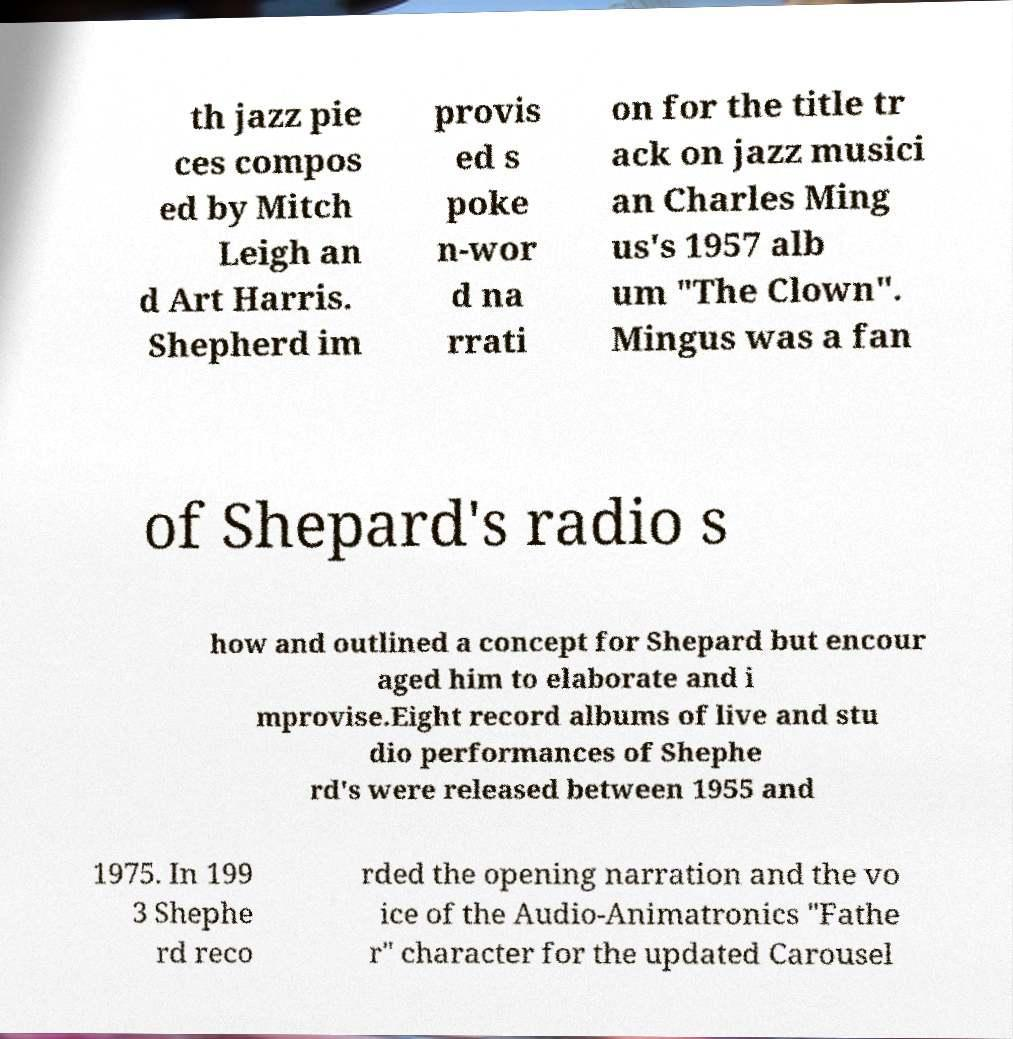Please identify and transcribe the text found in this image. th jazz pie ces compos ed by Mitch Leigh an d Art Harris. Shepherd im provis ed s poke n-wor d na rrati on for the title tr ack on jazz musici an Charles Ming us's 1957 alb um "The Clown". Mingus was a fan of Shepard's radio s how and outlined a concept for Shepard but encour aged him to elaborate and i mprovise.Eight record albums of live and stu dio performances of Shephe rd's were released between 1955 and 1975. In 199 3 Shephe rd reco rded the opening narration and the vo ice of the Audio-Animatronics "Fathe r" character for the updated Carousel 